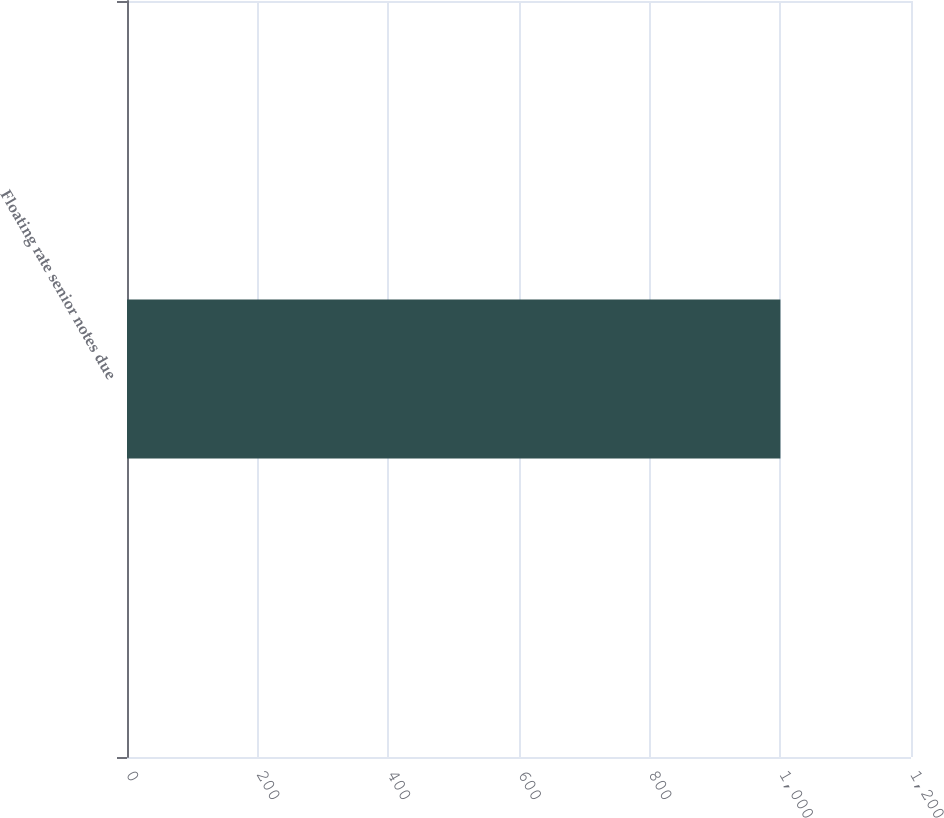Convert chart. <chart><loc_0><loc_0><loc_500><loc_500><bar_chart><fcel>Floating rate senior notes due<nl><fcel>1000.1<nl></chart> 